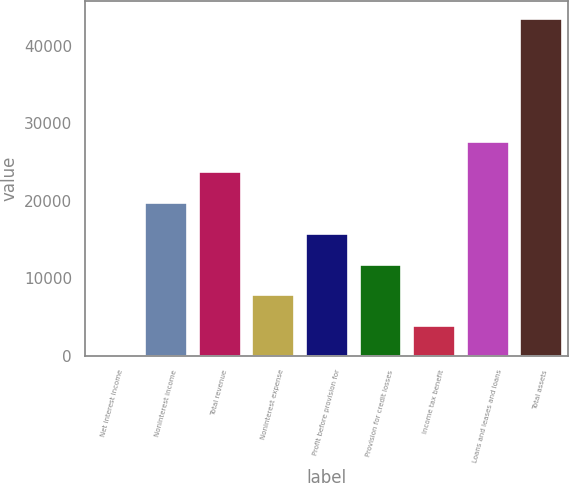Convert chart. <chart><loc_0><loc_0><loc_500><loc_500><bar_chart><fcel>Net interest income<fcel>Noninterest income<fcel>Total revenue<fcel>Noninterest expense<fcel>Profit before provision for<fcel>Provision for credit losses<fcel>Income tax benefit<fcel>Loans and leases and loans<fcel>Total assets<nl><fcel>27<fcel>19831.5<fcel>23792.4<fcel>7948.8<fcel>15870.6<fcel>11909.7<fcel>3987.9<fcel>27753.3<fcel>43596.9<nl></chart> 